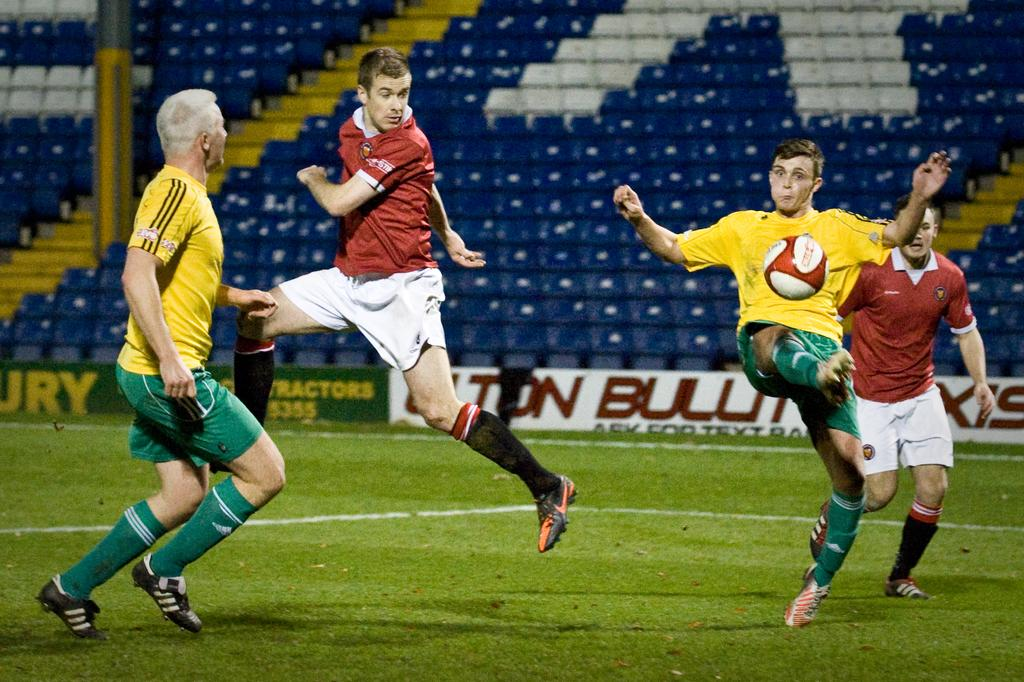<image>
Offer a succinct explanation of the picture presented. Soccer athetes on a field that is sponsored by some tractor company. 